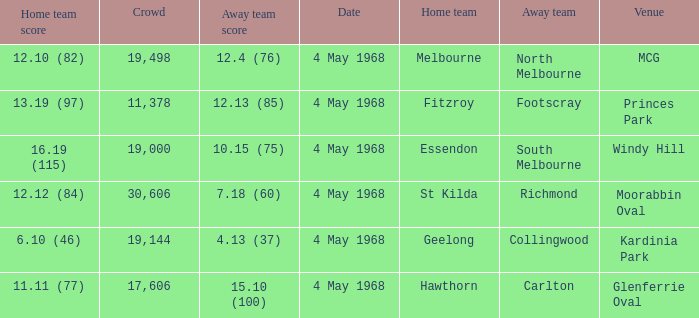How big was the crowd of the team that scored 4.13 (37)? 19144.0. 